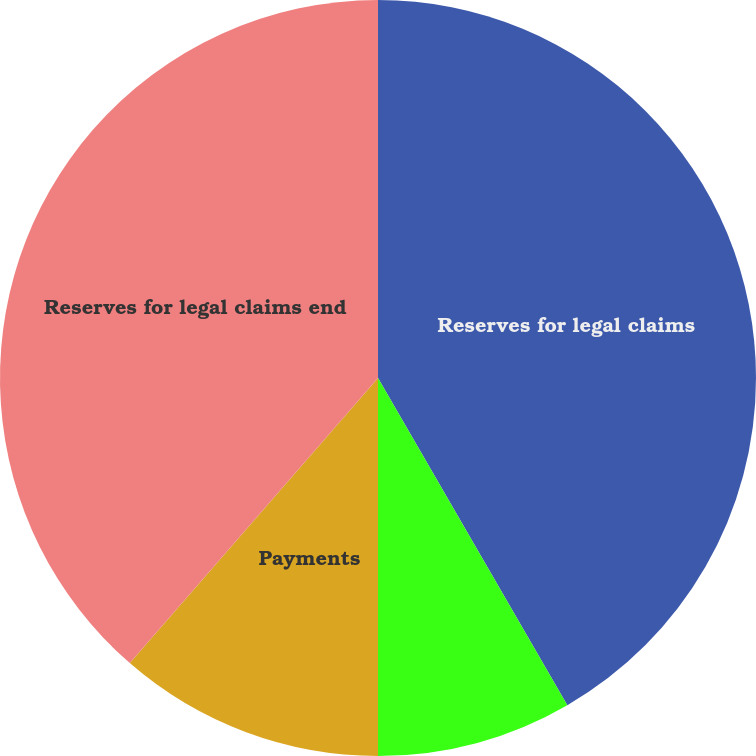<chart> <loc_0><loc_0><loc_500><loc_500><pie_chart><fcel>Reserves for legal claims<fcel>Increase in reserves<fcel>Payments<fcel>Reserves for legal claims end<nl><fcel>41.65%<fcel>8.35%<fcel>11.4%<fcel>38.6%<nl></chart> 